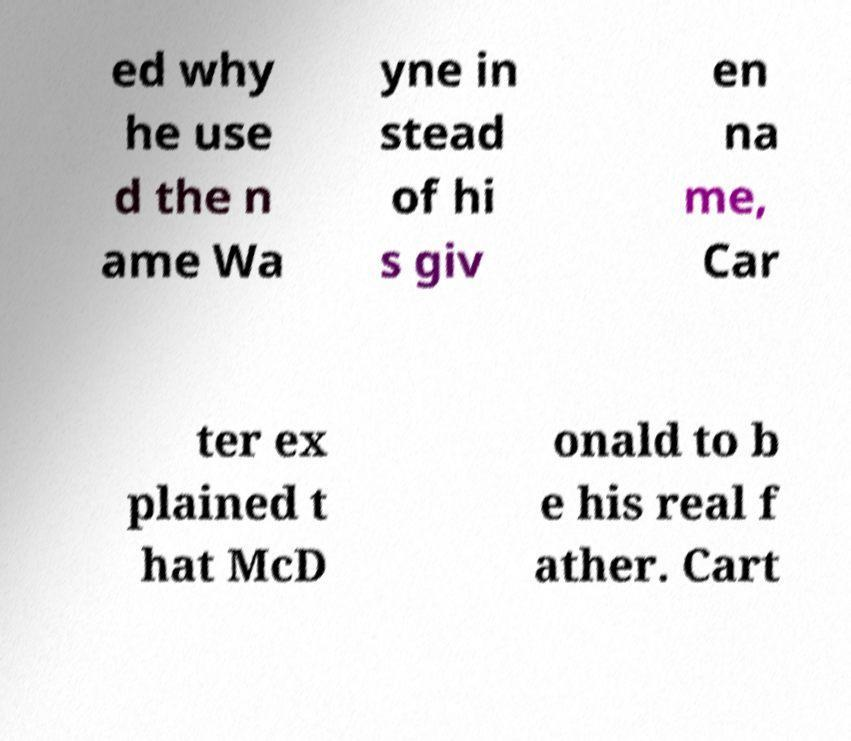Could you assist in decoding the text presented in this image and type it out clearly? ed why he use d the n ame Wa yne in stead of hi s giv en na me, Car ter ex plained t hat McD onald to b e his real f ather. Cart 